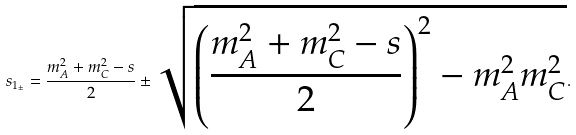<formula> <loc_0><loc_0><loc_500><loc_500>s _ { 1 _ { \pm } } = \frac { m ^ { 2 } _ { A } + m ^ { 2 } _ { C } - s } { 2 } \pm \sqrt { \left ( \frac { m ^ { 2 } _ { A } + m ^ { 2 } _ { C } - s } { 2 } \right ) ^ { 2 } - m _ { A } ^ { 2 } m _ { C } ^ { 2 } } .</formula> 